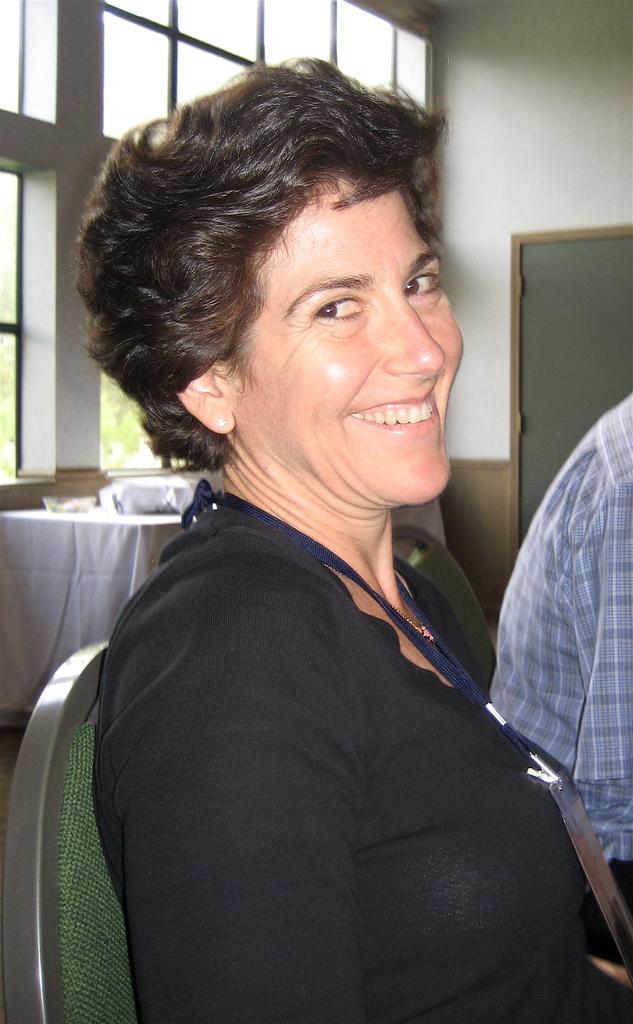Please provide a concise description of this image. In the center of the image we can see a lady is sitting on a chair and smiling. On the right side of the image we can see a person. In the middle of the image we can see a table. On the table we can see a cloth and some objects. In the background of the image we can see the wall, board, windows. 